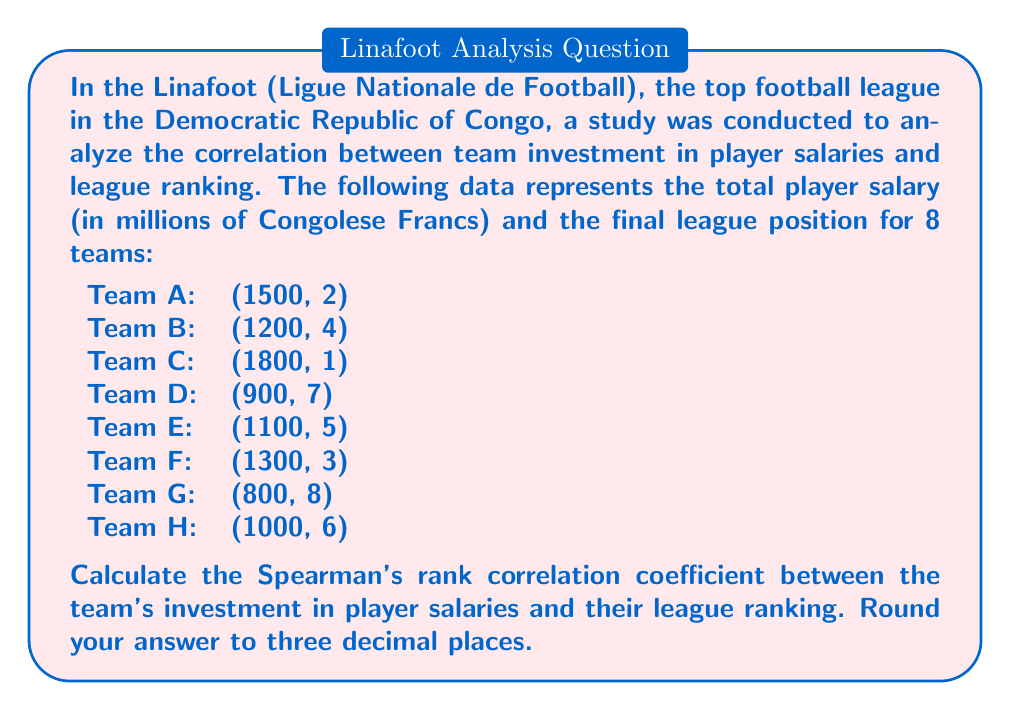Can you solve this math problem? To calculate Spearman's rank correlation coefficient, we need to follow these steps:

1. Rank the data for both variables (salary and league position).
2. Calculate the difference in ranks (d) for each team.
3. Square the differences (d²).
4. Sum up the squared differences (Σd²).
5. Apply the formula: $$ r_s = 1 - \frac{6\sum d^2}{n(n^2-1)} $$

where $r_s$ is Spearman's rank correlation coefficient, $n$ is the number of pairs.

Let's start by ranking the data:

Team | Salary | Salary Rank | Position | Position Rank | d | d²
-----|--------|-------------|----------|---------------|---|---
C    | 1800   | 1           | 1        | 1             | 0 | 0
A    | 1500   | 2           | 2        | 2             | 0 | 0
F    | 1300   | 3           | 3        | 3             | 0 | 0
B    | 1200   | 4           | 4        | 4             | 0 | 0
E    | 1100   | 5           | 5        | 5             | 0 | 0
H    | 1000   | 6           | 6        | 6             | 0 | 0
D    | 900    | 7           | 7        | 7             | 0 | 0
G    | 800    | 8           | 8        | 8             | 0 | 0

Now, we can calculate:

$\sum d^2 = 0$

$n = 8$

Applying the formula:

$$ r_s = 1 - \frac{6 \cdot 0}{8(8^2-1)} = 1 - \frac{0}{8(64-1)} = 1 - 0 = 1 $$

The Spearman's rank correlation coefficient is 1.000 (rounded to three decimal places).
Answer: 1.000 